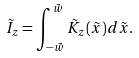<formula> <loc_0><loc_0><loc_500><loc_500>\tilde { I } _ { z } = \int _ { - \tilde { w } } ^ { \tilde { w } } \tilde { K } _ { z } ( \tilde { x } ) d \tilde { x } .</formula> 